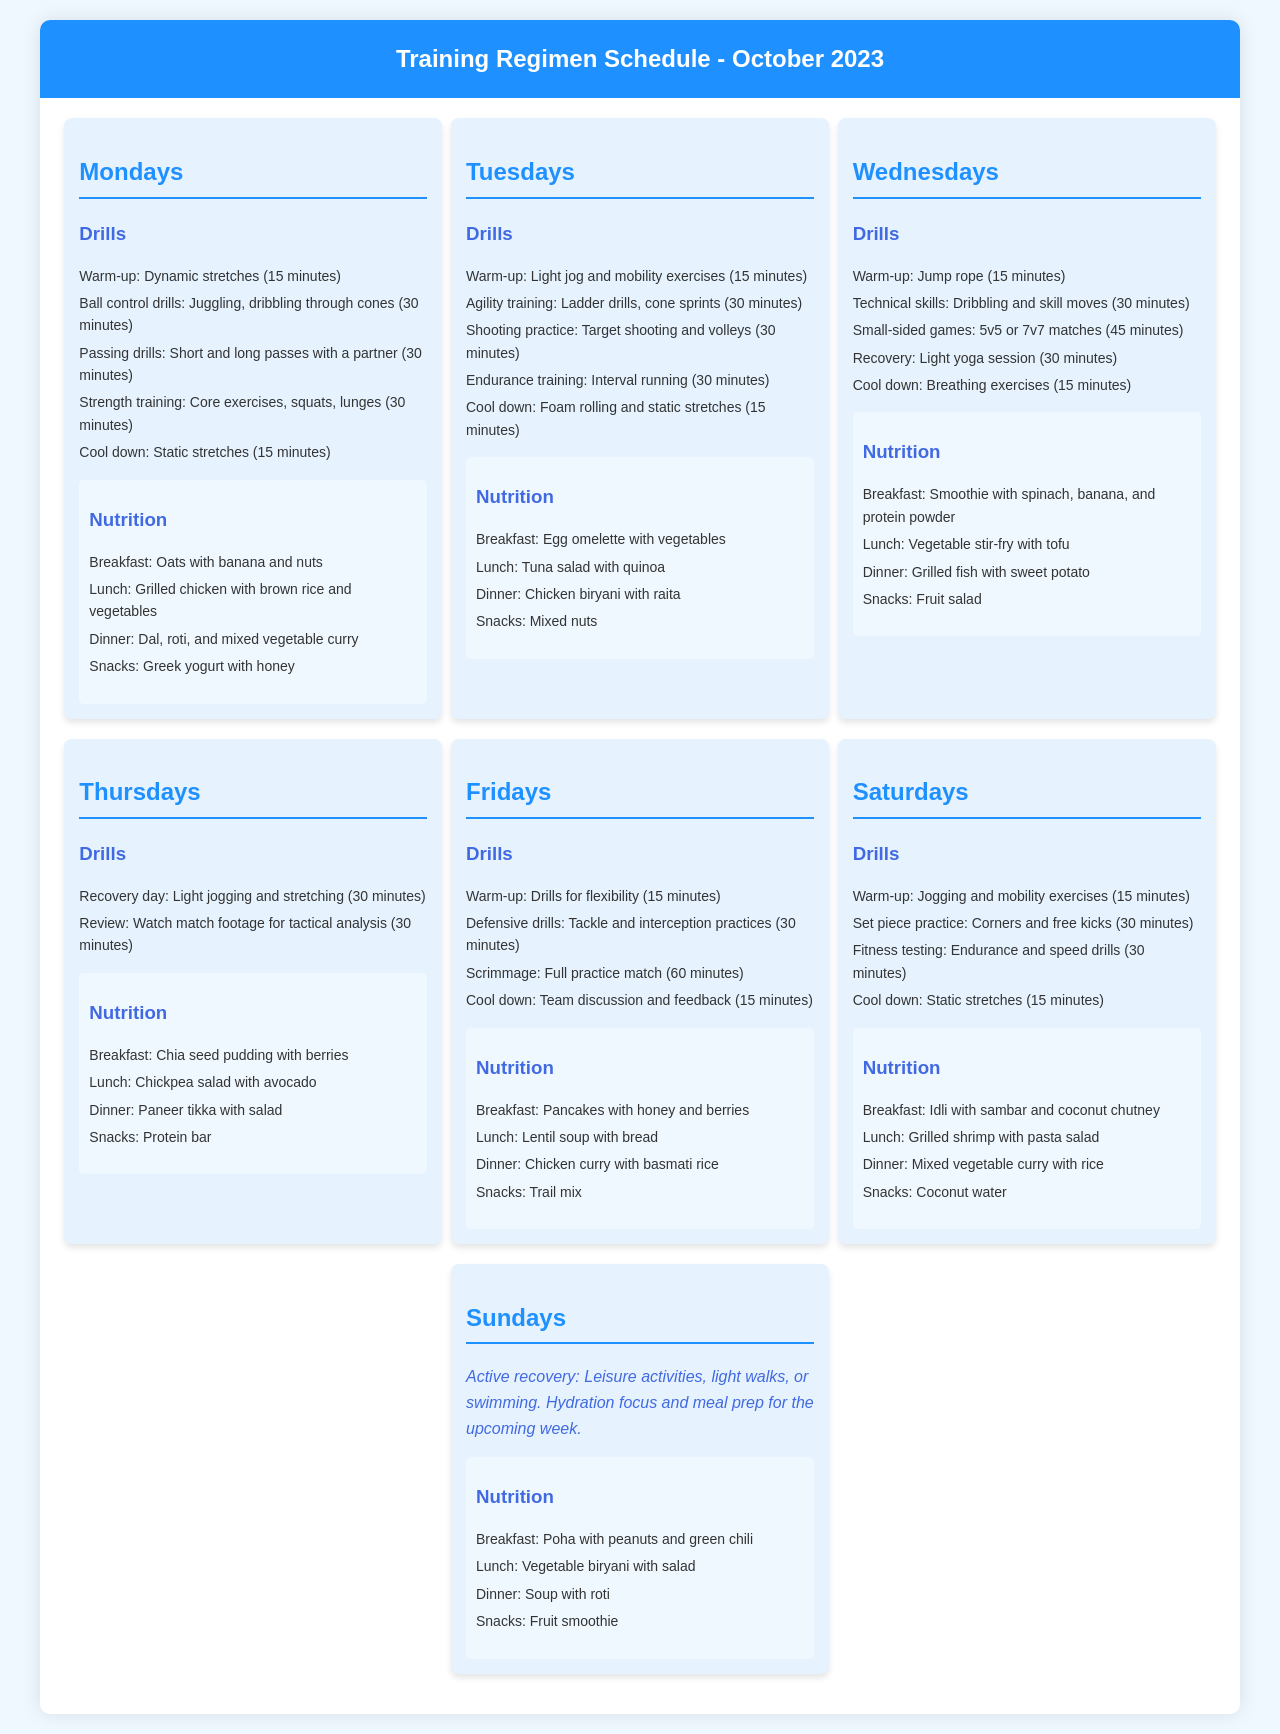What drills are done on Mondays? The drills listed for Mondays include warm-up, ball control drills, passing drills, strength training, and cool down.
Answer: Warm-up, ball control drills, passing drills, strength training, cool down What is the breakfast option for Wednesdays? The document specifies that breakfast for Wednesdays is a smoothie with spinach, banana, and protein powder.
Answer: Smoothie with spinach, banana, and protein powder How long is the small-sided games drill on Wednesdays? The small-sided games drill lasts for 45 minutes, as specified in the document.
Answer: 45 minutes What type of training is done on Tuesdays that focuses on speed? Agility training is emphasized on Tuesdays, which includes ladder drills and cone sprints.
Answer: Agility training What is the primary focus of Sundays? Sundays are designated for active recovery with leisure activities, light walks, or swimming.
Answer: Active recovery What meal is suggested for snacks on Saturdays? The snacks for Saturdays include coconut water, as detailed in the nutrition section.
Answer: Coconut water How many days in the week include strength training drills? Strength training drills are scheduled for Mondays and Fridays, making it two days in total.
Answer: Two days What type of recovery is included on Thursdays? The document states that Thursdays focus on recovery with light jogging and stretching.
Answer: Light jogging and stretching 